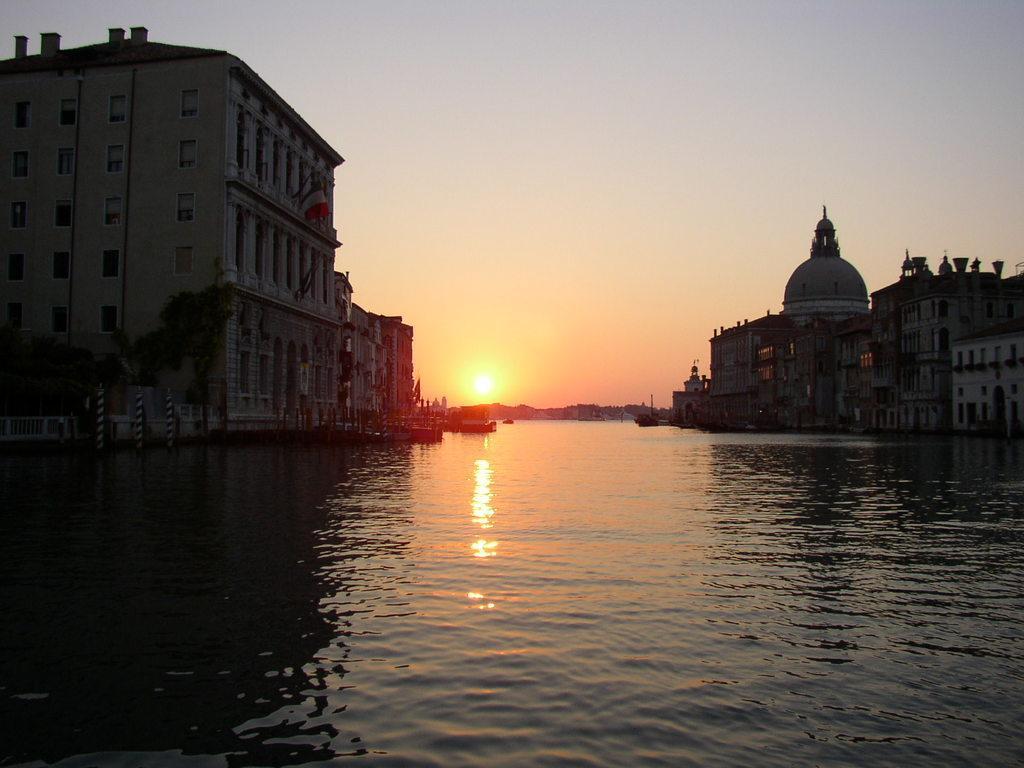How would you summarize this image in a sentence or two? In this image we can see buildings. In the center of the image there is water. In the background of the image there is sky and sun. 